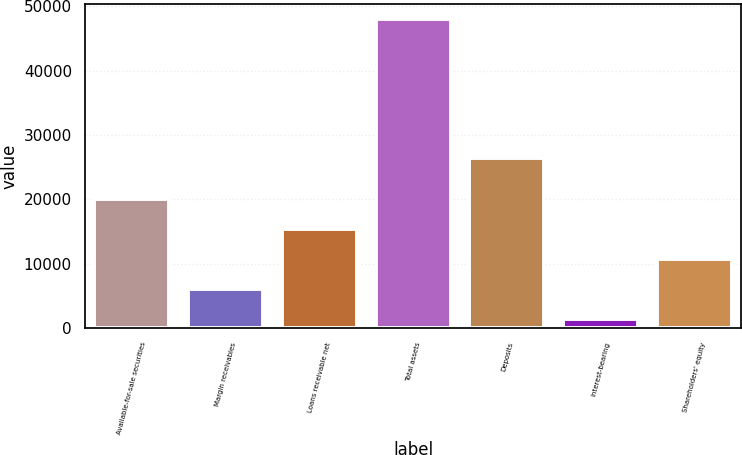Convert chart. <chart><loc_0><loc_0><loc_500><loc_500><bar_chart><fcel>Available-for-sale securities<fcel>Margin receivables<fcel>Loans receivable net<fcel>Total assets<fcel>Deposits<fcel>Interest-bearing<fcel>Shareholders' equity<nl><fcel>20046.5<fcel>6099.5<fcel>15397.5<fcel>47940.5<fcel>26460<fcel>1450.5<fcel>10748.5<nl></chart> 